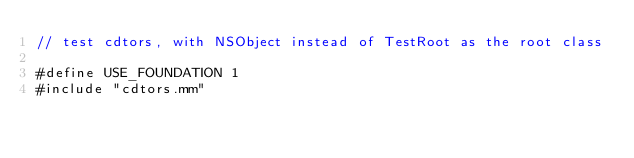<code> <loc_0><loc_0><loc_500><loc_500><_ObjectiveC_>// test cdtors, with NSObject instead of TestRoot as the root class

#define USE_FOUNDATION 1
#include "cdtors.mm"

</code> 